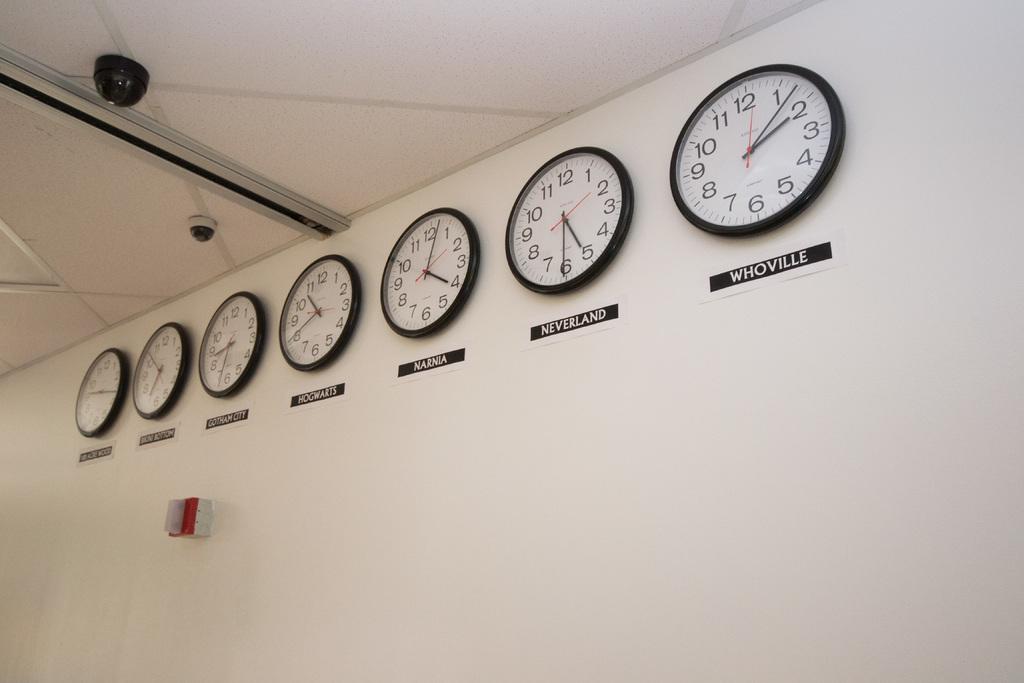What time is it in narnia?
Provide a short and direct response. 4:03. 